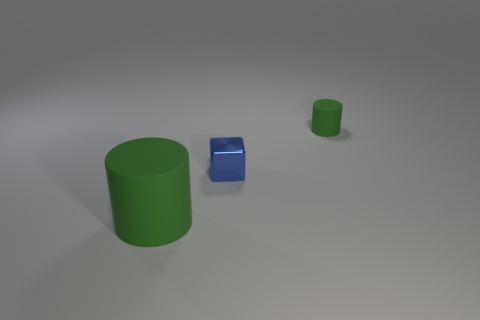Add 3 green rubber cylinders. How many objects exist? 6 Subtract all blocks. How many objects are left? 2 Subtract all small metallic cubes. Subtract all tiny matte objects. How many objects are left? 1 Add 2 green cylinders. How many green cylinders are left? 4 Add 1 blocks. How many blocks exist? 2 Subtract 0 blue cylinders. How many objects are left? 3 Subtract all gray blocks. Subtract all green spheres. How many blocks are left? 1 